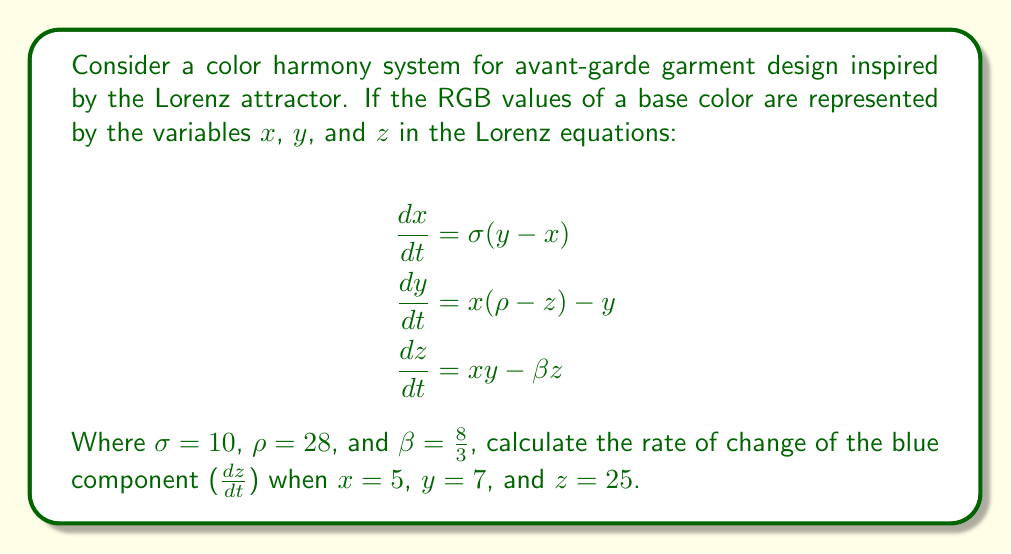What is the answer to this math problem? To solve this problem, we'll follow these steps:

1. Identify the equation for $\frac{dz}{dt}$ in the Lorenz system:
   $$\frac{dz}{dt} = xy - \beta z$$

2. Substitute the given values:
   $x = 5$
   $y = 7$
   $z = 25$
   $\beta = \frac{8}{3}$

3. Calculate $xy$:
   $xy = 5 \cdot 7 = 35$

4. Calculate $\beta z$:
   $\beta z = \frac{8}{3} \cdot 25 = \frac{200}{3}$

5. Substitute these values into the equation:
   $$\frac{dz}{dt} = 35 - \frac{200}{3}$$

6. Simplify the expression:
   $$\frac{dz}{dt} = 35 - \frac{200}{3} = \frac{105}{3} - \frac{200}{3} = -\frac{95}{3}$$

Therefore, the rate of change of the blue component is $-\frac{95}{3}$.
Answer: $-\frac{95}{3}$ 